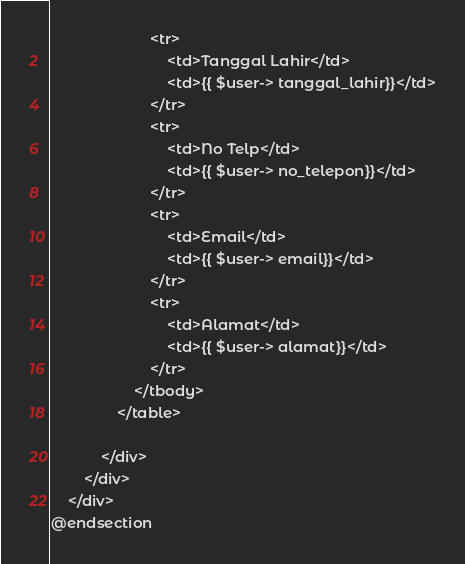<code> <loc_0><loc_0><loc_500><loc_500><_PHP_>                        <tr>
                            <td>Tanggal Lahir</td>
                            <td>{{ $user-> tanggal_lahir}}</td>
                        </tr>
                        <tr>
                            <td>No Telp</td>
                            <td>{{ $user-> no_telepon}}</td>
                        </tr>
                        <tr>
                            <td>Email</td>
                            <td>{{ $user-> email}}</td>
                        </tr>
                        <tr>
                            <td>Alamat</td>
                            <td>{{ $user-> alamat}}</td>
                        </tr>
                    </tbody>
                </table>
                
            </div>
        </div>
    </div>
@endsection</code> 